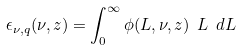Convert formula to latex. <formula><loc_0><loc_0><loc_500><loc_500>\epsilon _ { \nu , q } ( \nu , z ) = \int _ { 0 } ^ { \infty } \phi ( L , \nu , z ) \ L \ d L</formula> 